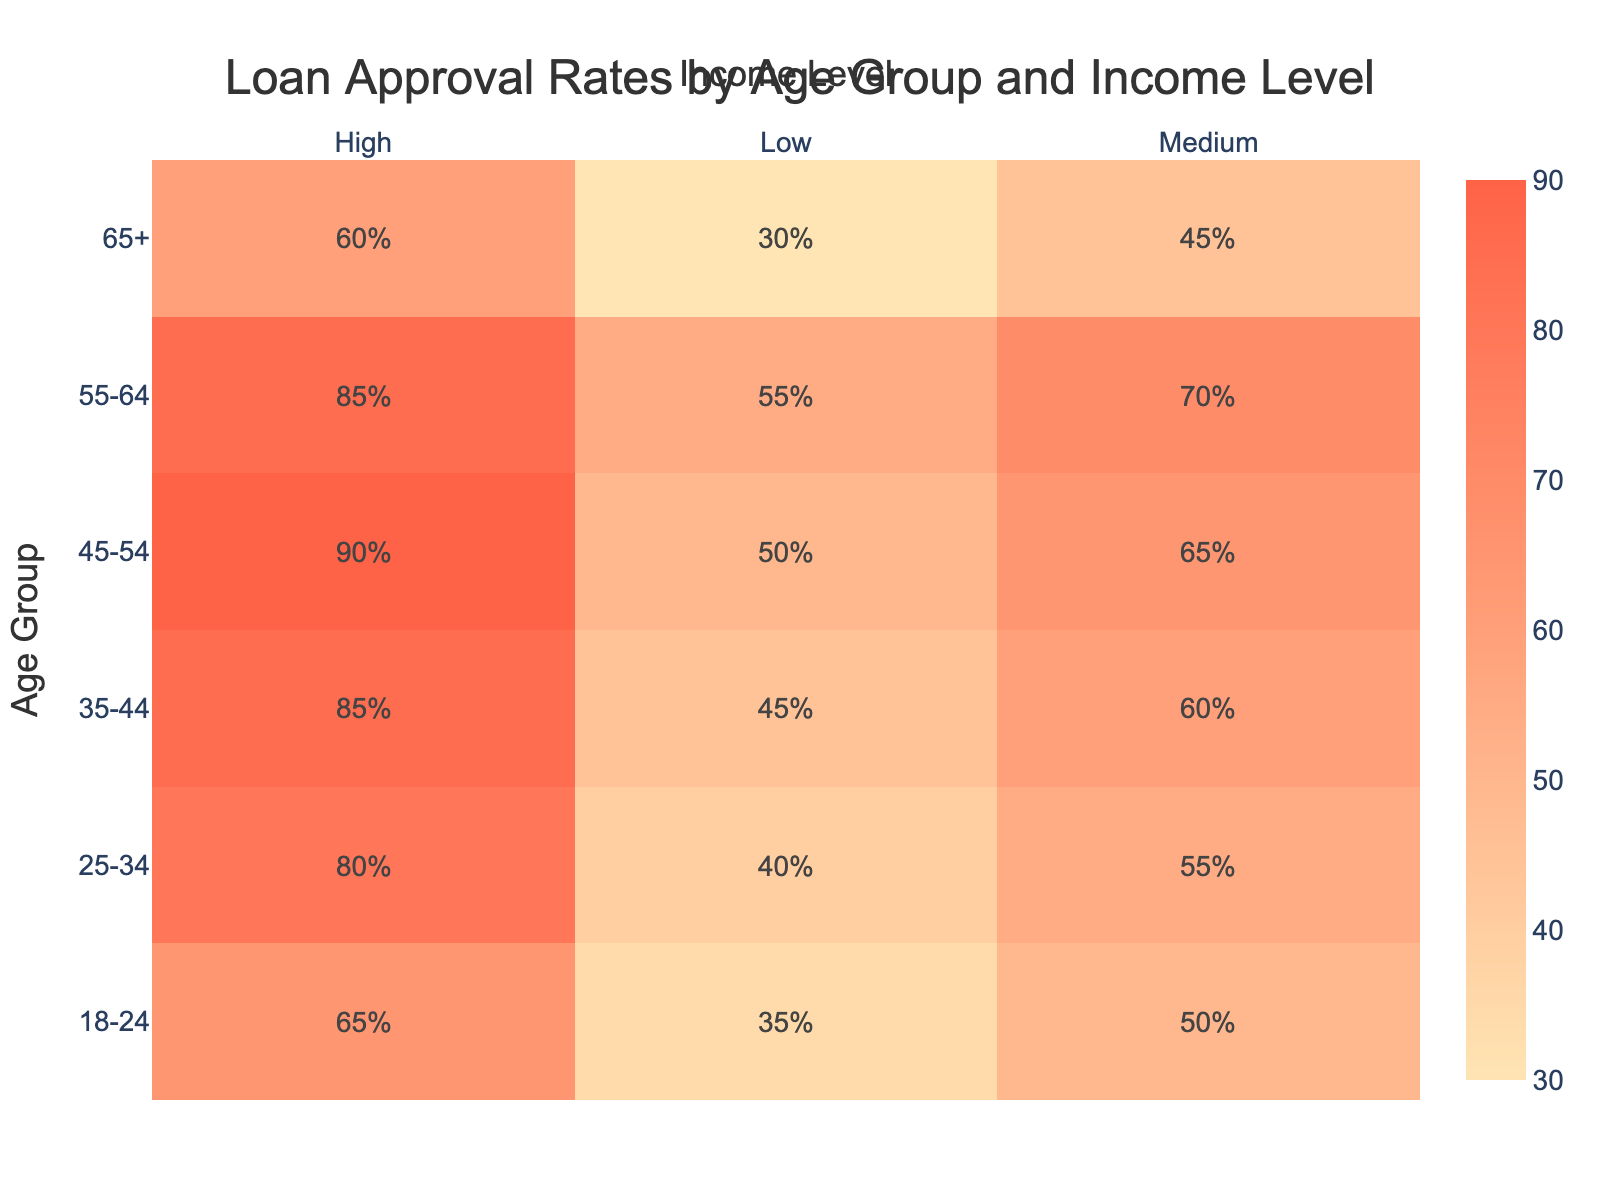What is the loan approval rate for those aged 25-34 with a medium income level? The table shows the loan approval rate for each age group and income level. For the age group 25-34 and income level medium, the loan approval rate is 55%.
Answer: 55 Which age group has the highest loan approval rate for high-income earners? By examining the table, we can see that the age group 45-54 has the highest loan approval rate for high-income earners at 90%.
Answer: 90 If we look at low-income earners, what age group has the lowest loan approval rate? The table indicates that for low-income earners, the age group 65+ has the lowest loan approval rate at 30%.
Answer: 30 What is the average loan approval rate for all age groups at the medium income level? To find the average, we need to sum the medium income approval rates: (50 + 55 + 60 + 65 + 70 + 45) = 445. There are 6 age groups, so the average is 445/6 = 74.17, which can be rounded to 74.
Answer: 74 Is the loan approval rate for the age group 18-24 with high income greater than the rate for those aged 35-44 with low income? The loan approval rate for age 18-24 with high income is 65%, while for age 35-44 with low income it is 45%. Since 65% is greater than 45%, the answer is yes.
Answer: Yes What is the difference in loan approval rates between 55-64 year-olds and 45-54 year-olds for low-income earners? For low-income earners, the approval rate for age group 55-64 is 55%, and for age group 45-54, it is 50%. The difference is 55 - 50 = 5.
Answer: 5 For which age group did loan approval rates not exceed 50% across all income levels? By looking at the table, we see that the age group 18-24 does not have any income level with an approval rate exceeding 65%, but the lowest rate at low income is 35%. However, 65+ age group has 30% at low income, 45% at medium income, and 60% at high income. Thus, the lowest overall loan approval rates are for the age group 65+.
Answer: 65+ What is the highest loan approval rate among the 25-34 age group? The table reveals that within the 25-34 age group, the highest loan approval rate is 80% for those at a high income level.
Answer: 80 